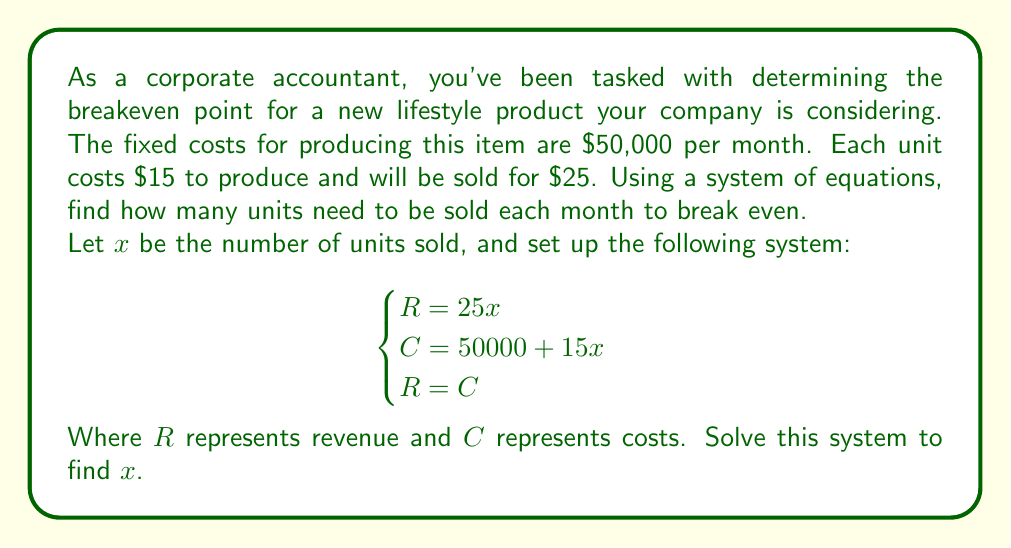Teach me how to tackle this problem. To solve this problem, we'll follow these steps:

1) First, let's understand what each equation represents:
   - $R = 25x$ : Revenue equation (price per unit * number of units)
   - $C = 50000 + 15x$ : Cost equation (fixed costs + variable costs per unit * number of units)
   - $R = C$ : Breakeven condition (revenue equals costs)

2) Now, we can substitute the first two equations into the third:
   
   $25x = 50000 + 15x$

3) Subtract $15x$ from both sides:
   
   $10x = 50000$

4) Divide both sides by 10:
   
   $x = 5000$

This means that 5,000 units need to be sold to break even.

5) We can verify this by plugging it back into our original equations:

   Revenue: $R = 25 * 5000 = 125000$
   Costs: $C = 50000 + 15 * 5000 = 125000$

   Indeed, $R = C$ at 5,000 units.
Answer: The breakeven point is 5,000 units. 